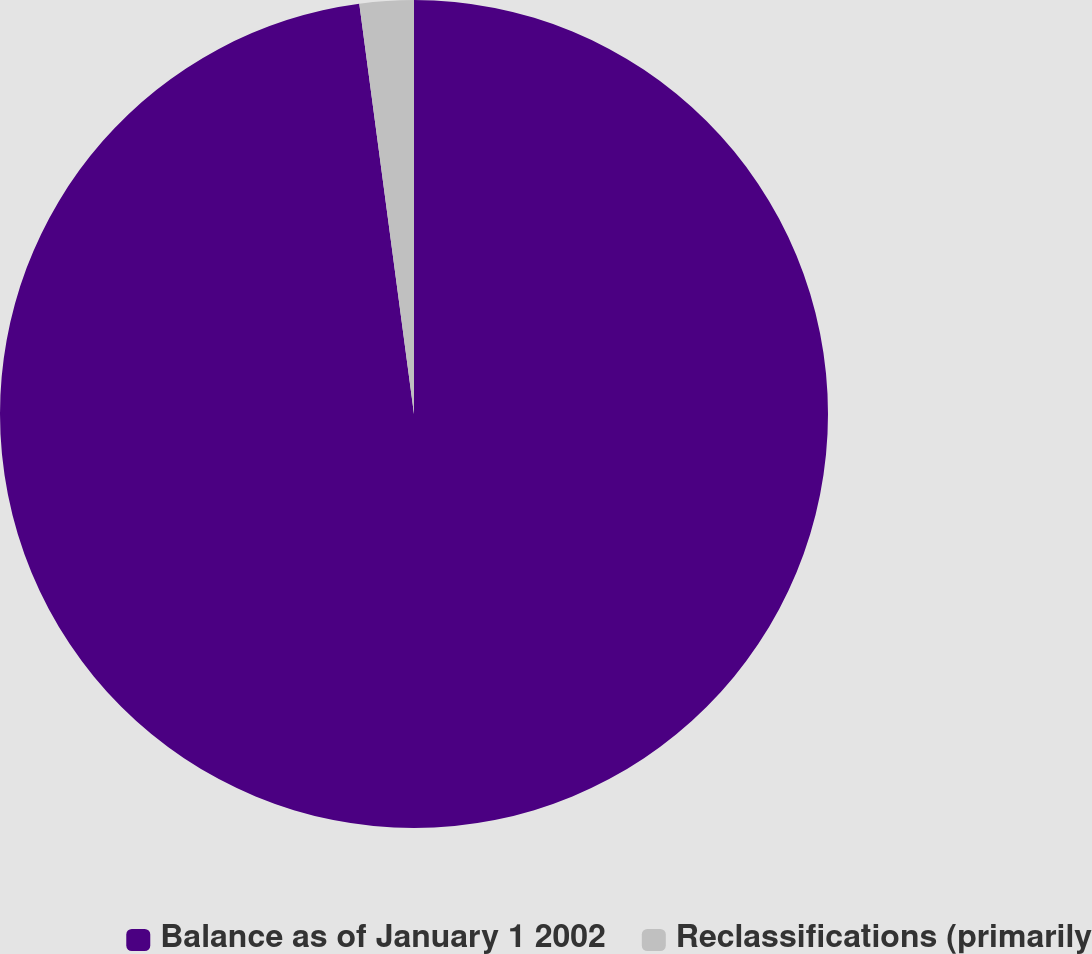Convert chart. <chart><loc_0><loc_0><loc_500><loc_500><pie_chart><fcel>Balance as of January 1 2002<fcel>Reclassifications (primarily<nl><fcel>97.89%<fcel>2.11%<nl></chart> 